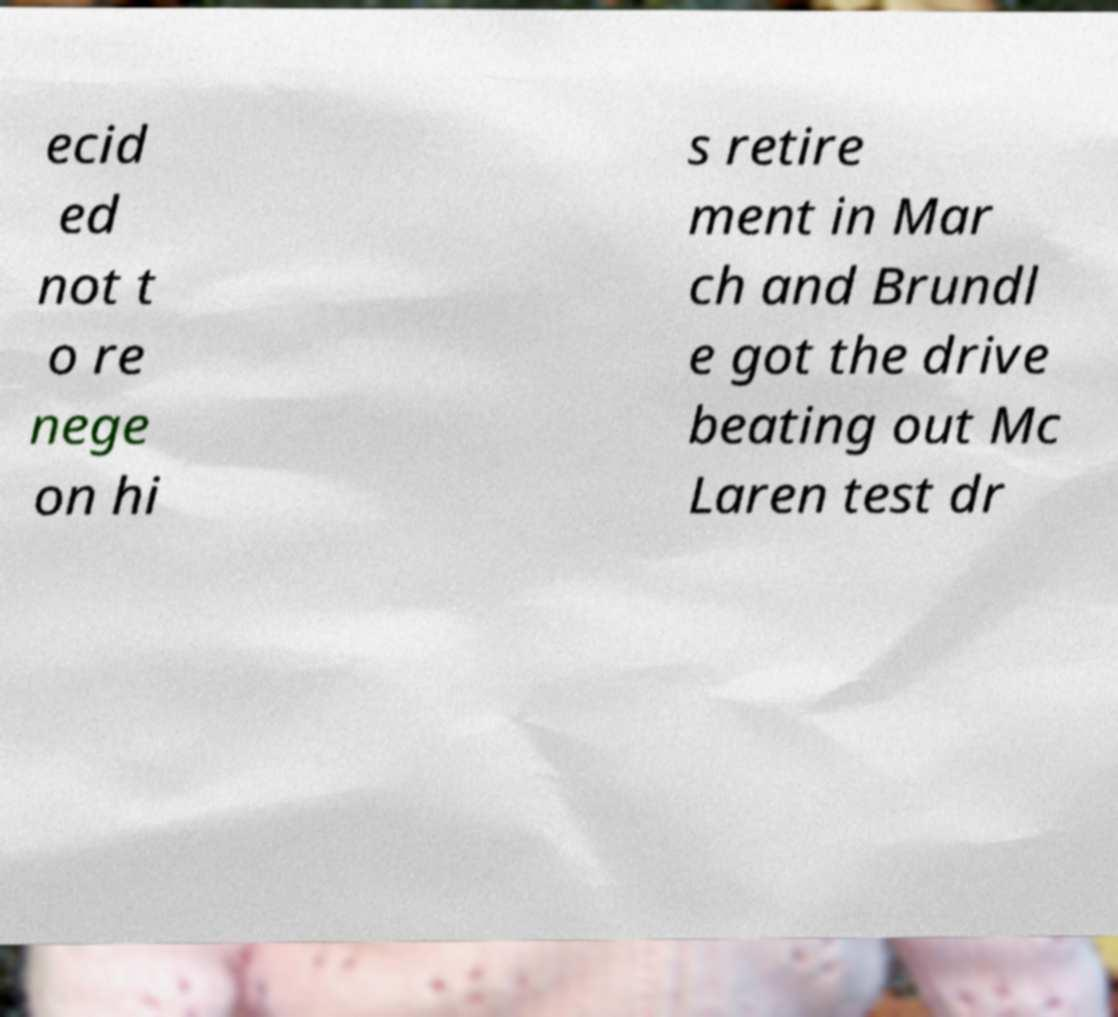Can you read and provide the text displayed in the image?This photo seems to have some interesting text. Can you extract and type it out for me? ecid ed not t o re nege on hi s retire ment in Mar ch and Brundl e got the drive beating out Mc Laren test dr 